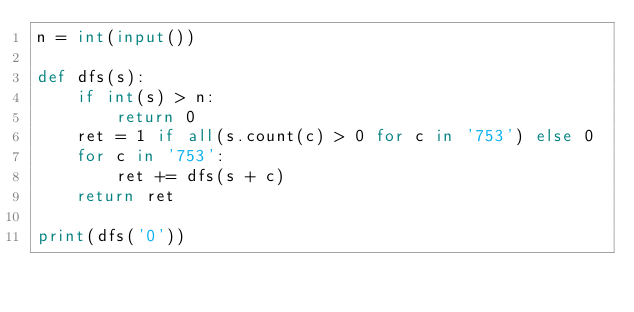<code> <loc_0><loc_0><loc_500><loc_500><_Python_>n = int(input())

def dfs(s):
    if int(s) > n:
        return 0
    ret = 1 if all(s.count(c) > 0 for c in '753') else 0
    for c in '753':
        ret += dfs(s + c)
    return ret

print(dfs('0'))</code> 